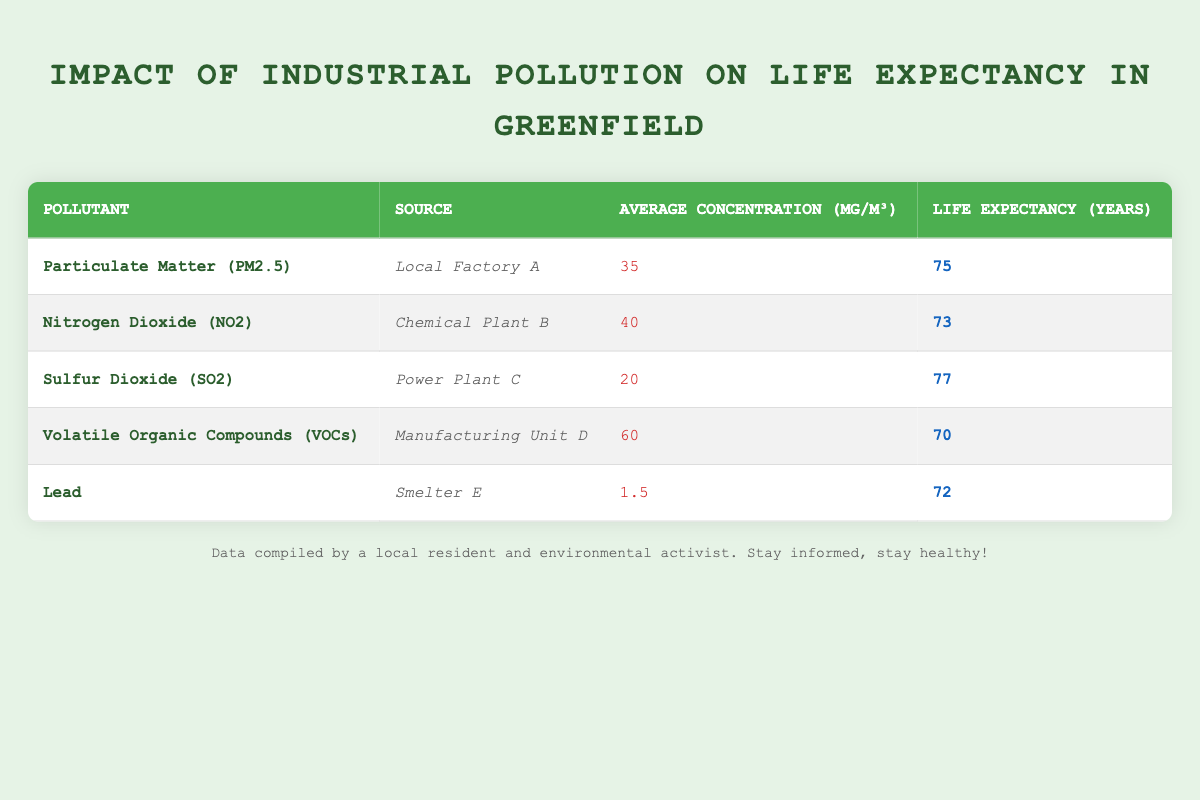What is the life expectancy associated with Particulate Matter (PM2.5)? According to the table, the life expectancy linked to Particulate Matter (PM2.5) is listed as 75 years.
Answer: 75 years Which pollutant has the highest average concentration in micrograms per cubic meter? The table indicates that Volatile Organic Compounds (VOCs) have the highest average concentration at 60 µg/m³.
Answer: 60 µg/m³ What is the difference in life expectancy between those exposed to Nitrogen Dioxide (NO2) and Sulfur Dioxide (SO2)? The life expectancy for Nitrogen Dioxide (NO2) is 73 years, while for Sulfur Dioxide (SO2) it is 77 years. The difference is calculated as 77 - 73 = 4 years.
Answer: 4 years Is the average concentration of Lead higher than that of Particulate Matter (PM2.5)? The average concentration of Lead is 1.5 µg/m³, which is significantly lower than that of Particulate Matter (PM2.5), which is 35 µg/m³. Therefore, the statement is false.
Answer: No Which source of pollution is associated with the lowest life expectancy? From the table, the source with the lowest life expectancy is Volatile Organic Compounds (VOCs) at 70 years, in comparison to the other sources.
Answer: 70 years Calculate the average life expectancy for all pollutants listed in the table. To calculate the average life expectancy, sum the life expectancies: 75 + 73 + 77 + 70 + 72 = 367. Then divide by the number of pollutants (5). Thus, 367 / 5 = 73.4 years.
Answer: 73.4 years Does the average concentration of Nitrogen Dioxide (NO2) exceed the average of the other pollutants? The average concentration of Nitrogen Dioxide (NO2) is 40 µg/m³. The average of the other pollutants can be calculated as (35 + 20 + 60 + 1.5) / 4 = 29.125 µg/m³. Since 40 > 29.125, this statement is true.
Answer: Yes What pollutants are associated with a life expectancy of 72 years? The table shows that Lead is the only pollutant associated with a life expectancy of 72 years.
Answer: Lead What is the combined life expectancy of those exposed to Sulfur Dioxide (SO2) and Lead? Sulfur Dioxide (SO2) has a life expectancy of 77 years and Lead has 72 years. The combined life expectancy is calculated as 77 + 72 = 149 years.
Answer: 149 years 